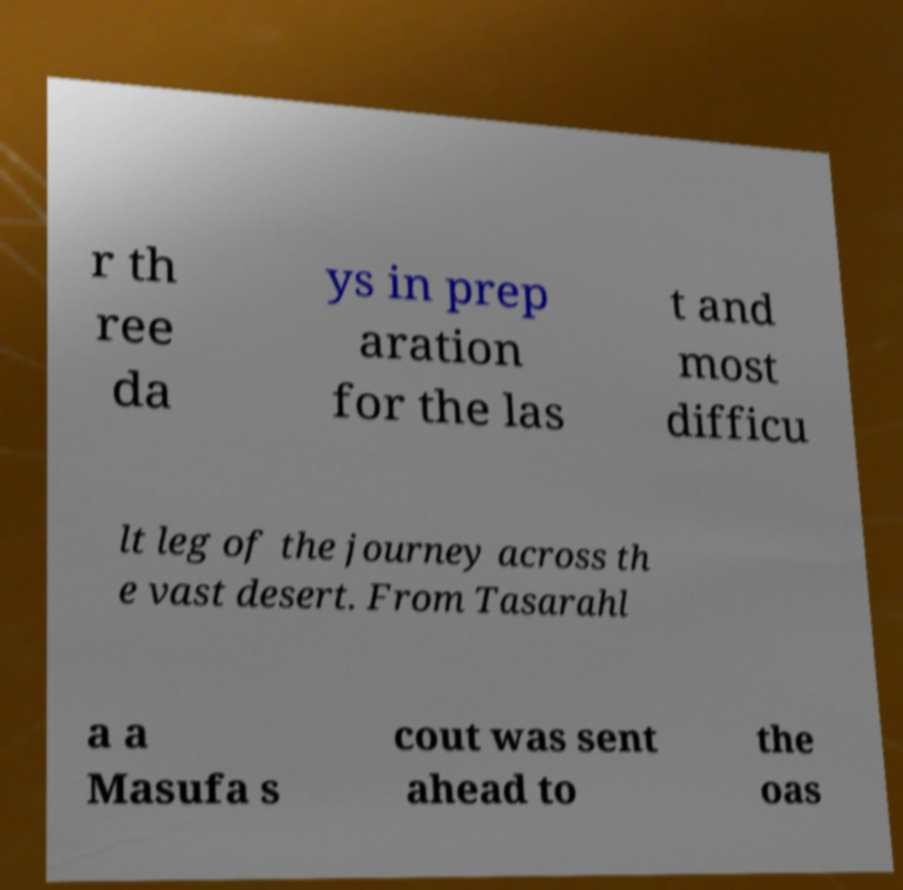Please identify and transcribe the text found in this image. r th ree da ys in prep aration for the las t and most difficu lt leg of the journey across th e vast desert. From Tasarahl a a Masufa s cout was sent ahead to the oas 